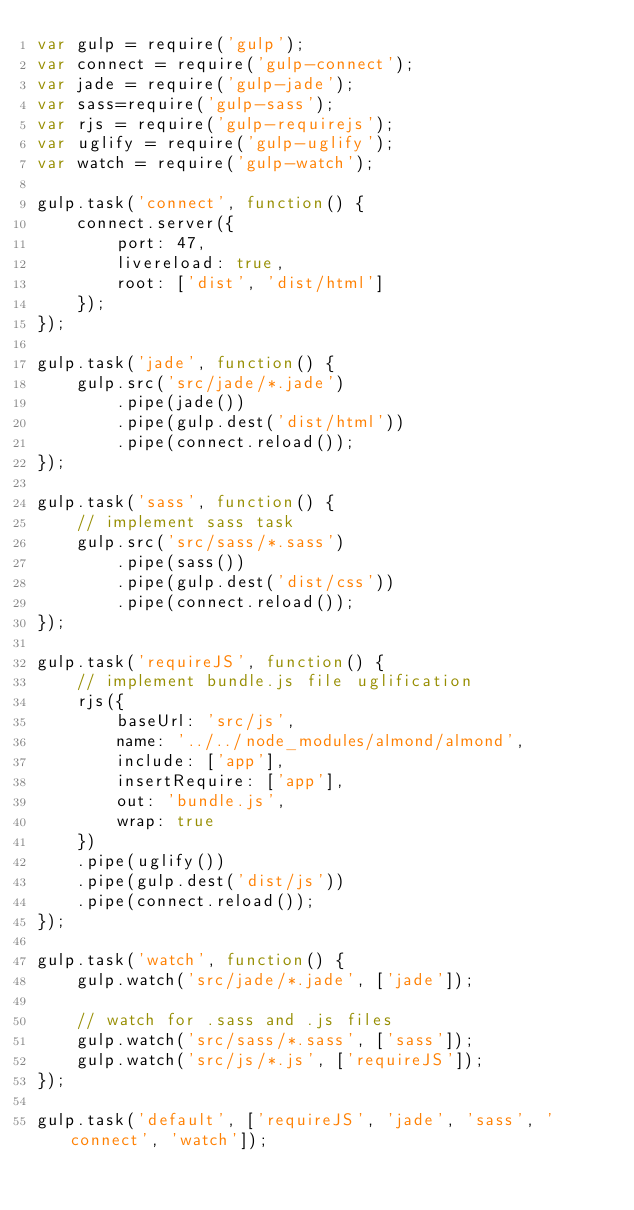Convert code to text. <code><loc_0><loc_0><loc_500><loc_500><_JavaScript_>var gulp = require('gulp');
var connect = require('gulp-connect');
var jade = require('gulp-jade');
var sass=require('gulp-sass');
var rjs = require('gulp-requirejs');
var uglify = require('gulp-uglify');
var watch = require('gulp-watch');

gulp.task('connect', function() {
	connect.server({
		port: 47,
		livereload: true,
		root: ['dist', 'dist/html']
	});
});

gulp.task('jade', function() {
	gulp.src('src/jade/*.jade')
		.pipe(jade())
		.pipe(gulp.dest('dist/html'))
		.pipe(connect.reload());
});

gulp.task('sass', function() {
	// implement sass task
	gulp.src('src/sass/*.sass')
		.pipe(sass())
		.pipe(gulp.dest('dist/css'))
		.pipe(connect.reload());
});

gulp.task('requireJS', function() {
	// implement bundle.js file uglification
	rjs({
		baseUrl: 'src/js',
		name: '../../node_modules/almond/almond',
		include: ['app'],
		insertRequire: ['app'],
		out: 'bundle.js',
		wrap: true
	})
	.pipe(uglify())
	.pipe(gulp.dest('dist/js'))
	.pipe(connect.reload());
});

gulp.task('watch', function() {
	gulp.watch('src/jade/*.jade', ['jade']);

	// watch for .sass and .js files
	gulp.watch('src/sass/*.sass', ['sass']);
	gulp.watch('src/js/*.js', ['requireJS']);
});

gulp.task('default', ['requireJS', 'jade', 'sass', 'connect', 'watch']);</code> 